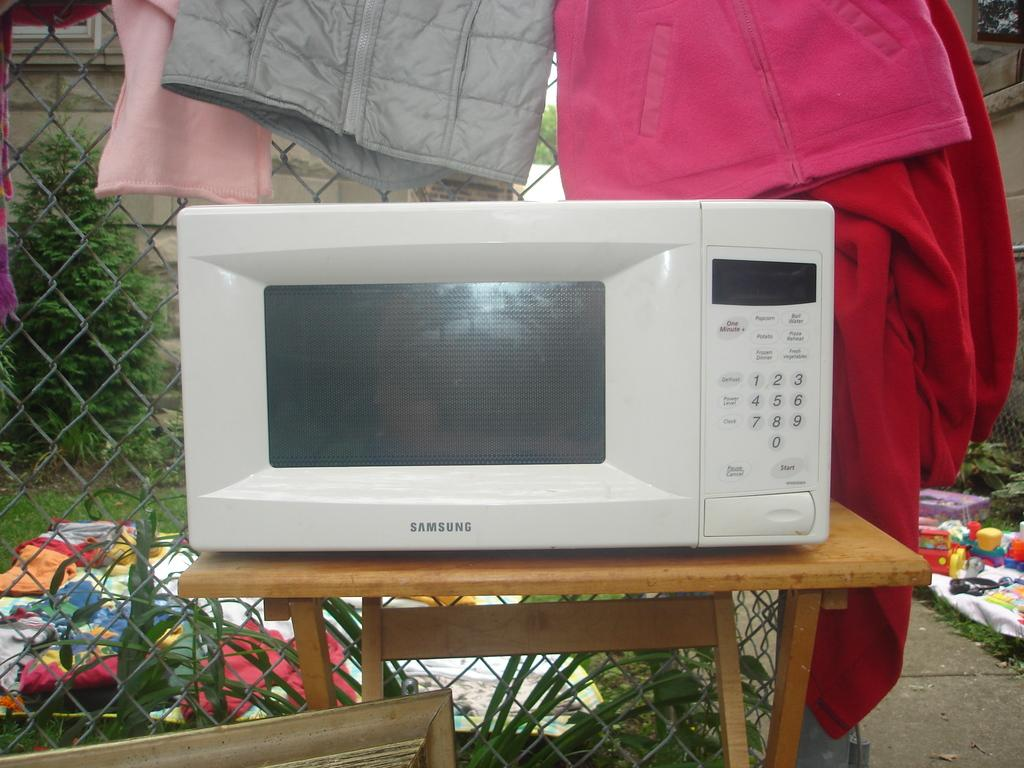<image>
Create a compact narrative representing the image presented. a Samsung white microwave oven on a wood table outside 